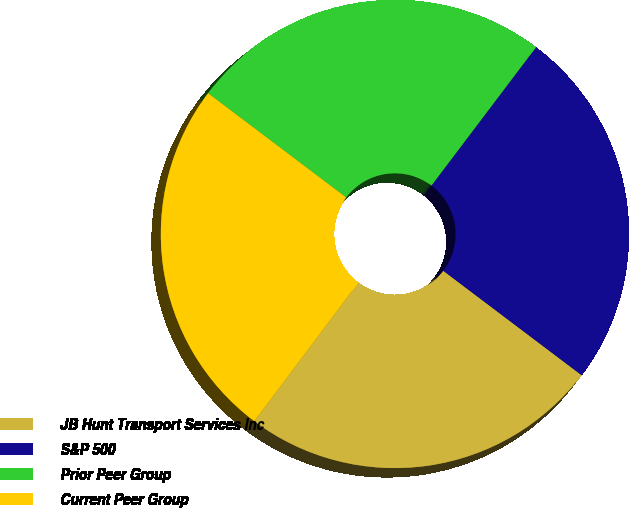Convert chart to OTSL. <chart><loc_0><loc_0><loc_500><loc_500><pie_chart><fcel>JB Hunt Transport Services Inc<fcel>S&P 500<fcel>Prior Peer Group<fcel>Current Peer Group<nl><fcel>24.96%<fcel>24.99%<fcel>25.01%<fcel>25.04%<nl></chart> 